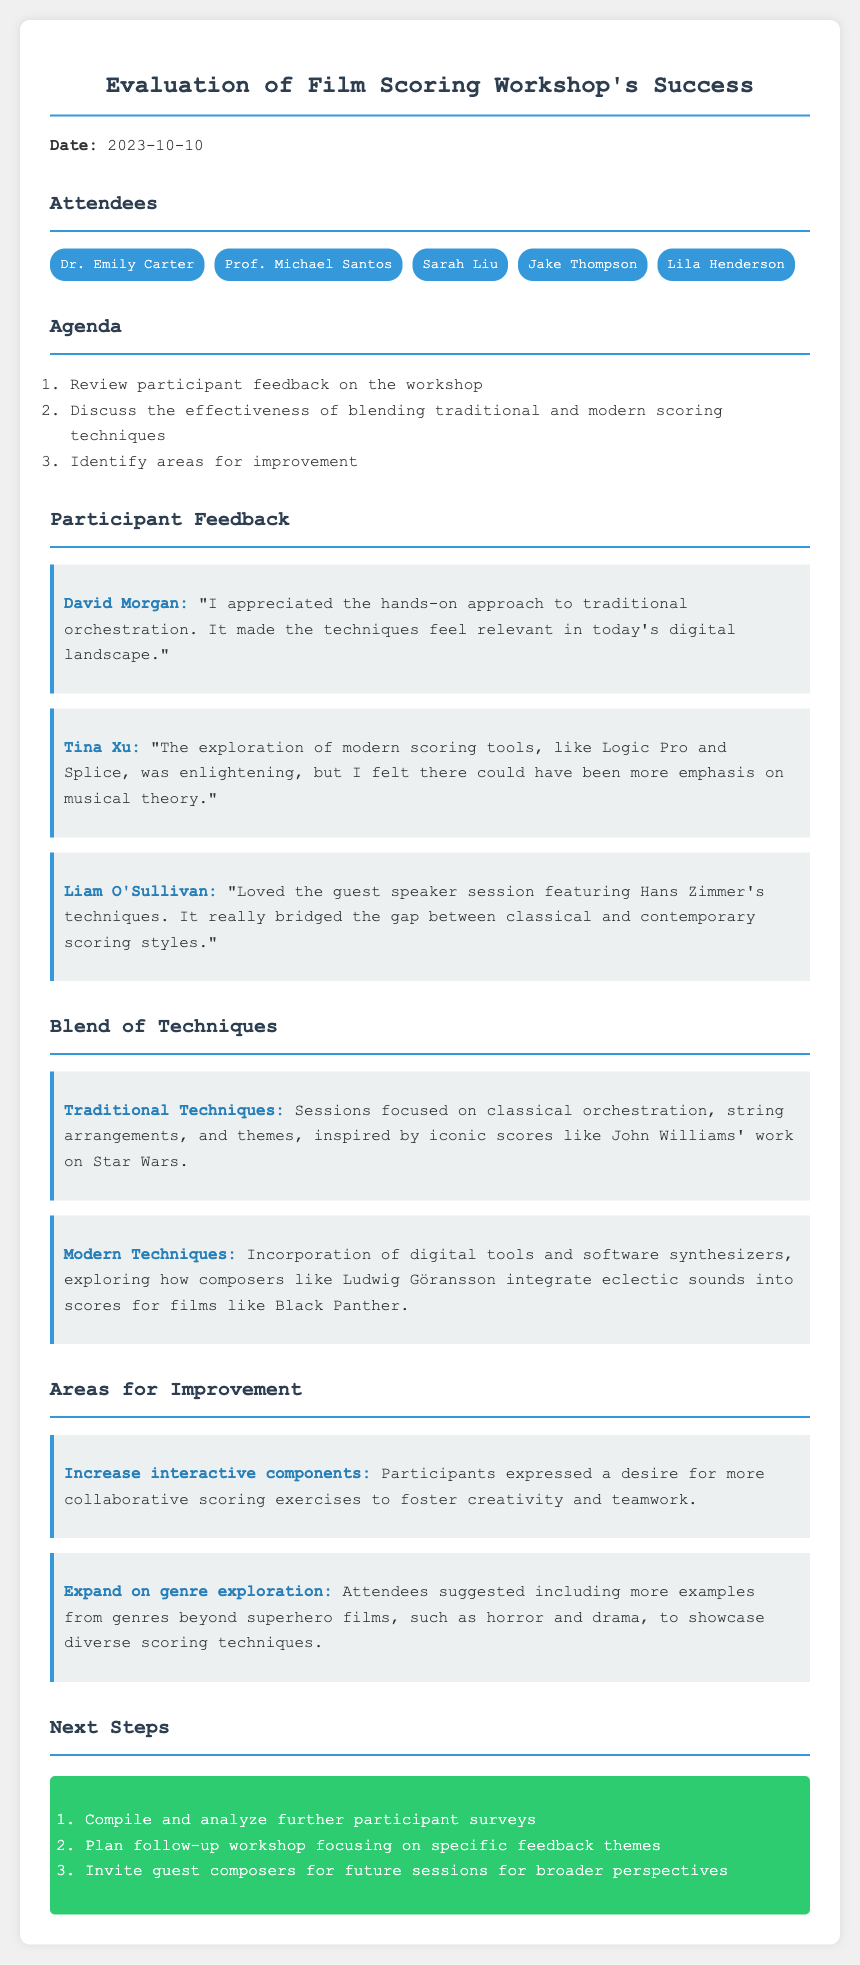What is the date of the workshop evaluation? The date is mentioned at the beginning of the document.
Answer: 2023-10-10 Who expressed appreciation for the hands-on approach to traditional orchestration? This information can be found in the participant feedback section.
Answer: David Morgan What specific modern scoring tool did Tina Xu find enlightening? This detail is included in her feedback comment.
Answer: Logic Pro Which composer’s techniques were featured during the guest speaker session? The document specifies the guest speaker's identity in the participant feedback section.
Answer: Hans Zimmer What traditional scoring aspects were covered in the workshop? This information summarizes the traditional techniques discussed.
Answer: Classical orchestration, string arrangements, themes What did participants suggest to increase interactivity in the workshop? This detail is found in the areas for improvement section.
Answer: Collaborative scoring exercises How many attendees are listed in the meeting minutes? The number is determined by counting the names in the attendees section.
Answer: 5 What genre exploration expansion did attendees suggest? This is mentioned in the areas for improvement section regarding genres.
Answer: More examples from genres beyond superhero films 